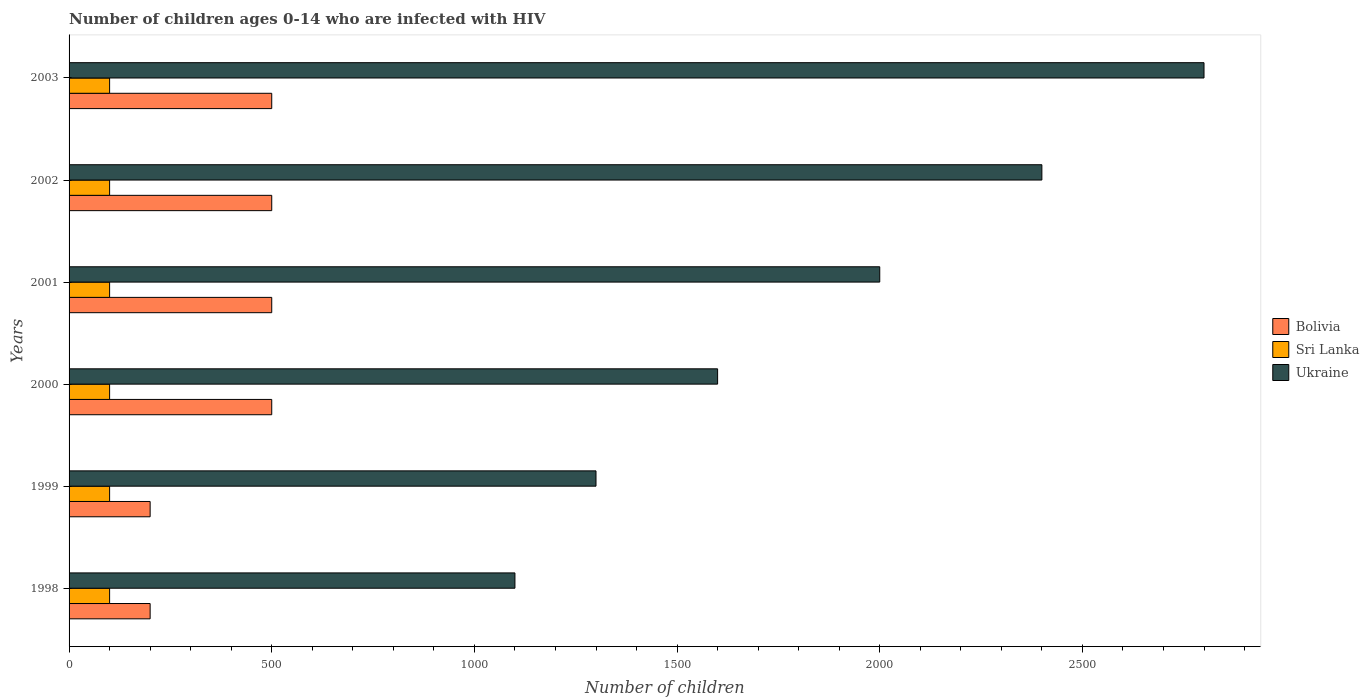How many different coloured bars are there?
Offer a very short reply. 3. Are the number of bars per tick equal to the number of legend labels?
Your response must be concise. Yes. How many bars are there on the 2nd tick from the bottom?
Offer a very short reply. 3. What is the number of HIV infected children in Ukraine in 2001?
Your answer should be compact. 2000. Across all years, what is the maximum number of HIV infected children in Ukraine?
Your answer should be compact. 2800. Across all years, what is the minimum number of HIV infected children in Ukraine?
Keep it short and to the point. 1100. In which year was the number of HIV infected children in Ukraine minimum?
Give a very brief answer. 1998. What is the total number of HIV infected children in Sri Lanka in the graph?
Offer a terse response. 600. What is the difference between the number of HIV infected children in Bolivia in 1999 and that in 2001?
Provide a short and direct response. -300. What is the difference between the number of HIV infected children in Sri Lanka in 1999 and the number of HIV infected children in Bolivia in 2003?
Offer a very short reply. -400. In the year 2001, what is the difference between the number of HIV infected children in Bolivia and number of HIV infected children in Ukraine?
Provide a short and direct response. -1500. Is the number of HIV infected children in Sri Lanka in 2002 less than that in 2003?
Provide a short and direct response. No. Is the difference between the number of HIV infected children in Bolivia in 1999 and 2003 greater than the difference between the number of HIV infected children in Ukraine in 1999 and 2003?
Offer a very short reply. Yes. What is the difference between the highest and the lowest number of HIV infected children in Ukraine?
Keep it short and to the point. 1700. In how many years, is the number of HIV infected children in Sri Lanka greater than the average number of HIV infected children in Sri Lanka taken over all years?
Provide a succinct answer. 0. What does the 3rd bar from the top in 2003 represents?
Give a very brief answer. Bolivia. What does the 2nd bar from the bottom in 2000 represents?
Offer a terse response. Sri Lanka. How many years are there in the graph?
Provide a short and direct response. 6. What is the difference between two consecutive major ticks on the X-axis?
Give a very brief answer. 500. Does the graph contain grids?
Ensure brevity in your answer.  No. Where does the legend appear in the graph?
Your answer should be compact. Center right. How many legend labels are there?
Your answer should be compact. 3. What is the title of the graph?
Provide a short and direct response. Number of children ages 0-14 who are infected with HIV. What is the label or title of the X-axis?
Keep it short and to the point. Number of children. What is the label or title of the Y-axis?
Give a very brief answer. Years. What is the Number of children of Sri Lanka in 1998?
Provide a short and direct response. 100. What is the Number of children of Ukraine in 1998?
Give a very brief answer. 1100. What is the Number of children in Ukraine in 1999?
Your answer should be very brief. 1300. What is the Number of children of Sri Lanka in 2000?
Keep it short and to the point. 100. What is the Number of children of Ukraine in 2000?
Keep it short and to the point. 1600. What is the Number of children of Bolivia in 2001?
Your response must be concise. 500. What is the Number of children in Sri Lanka in 2002?
Provide a short and direct response. 100. What is the Number of children in Ukraine in 2002?
Provide a short and direct response. 2400. What is the Number of children of Sri Lanka in 2003?
Give a very brief answer. 100. What is the Number of children of Ukraine in 2003?
Your response must be concise. 2800. Across all years, what is the maximum Number of children of Bolivia?
Your response must be concise. 500. Across all years, what is the maximum Number of children of Ukraine?
Provide a short and direct response. 2800. Across all years, what is the minimum Number of children of Bolivia?
Offer a very short reply. 200. Across all years, what is the minimum Number of children in Ukraine?
Keep it short and to the point. 1100. What is the total Number of children in Bolivia in the graph?
Keep it short and to the point. 2400. What is the total Number of children in Sri Lanka in the graph?
Provide a succinct answer. 600. What is the total Number of children of Ukraine in the graph?
Your answer should be compact. 1.12e+04. What is the difference between the Number of children in Bolivia in 1998 and that in 1999?
Ensure brevity in your answer.  0. What is the difference between the Number of children of Ukraine in 1998 and that in 1999?
Your response must be concise. -200. What is the difference between the Number of children of Bolivia in 1998 and that in 2000?
Provide a short and direct response. -300. What is the difference between the Number of children of Sri Lanka in 1998 and that in 2000?
Give a very brief answer. 0. What is the difference between the Number of children of Ukraine in 1998 and that in 2000?
Offer a terse response. -500. What is the difference between the Number of children of Bolivia in 1998 and that in 2001?
Offer a very short reply. -300. What is the difference between the Number of children of Ukraine in 1998 and that in 2001?
Your answer should be compact. -900. What is the difference between the Number of children of Bolivia in 1998 and that in 2002?
Keep it short and to the point. -300. What is the difference between the Number of children in Ukraine in 1998 and that in 2002?
Provide a short and direct response. -1300. What is the difference between the Number of children of Bolivia in 1998 and that in 2003?
Provide a succinct answer. -300. What is the difference between the Number of children of Ukraine in 1998 and that in 2003?
Your answer should be compact. -1700. What is the difference between the Number of children of Bolivia in 1999 and that in 2000?
Your answer should be very brief. -300. What is the difference between the Number of children in Sri Lanka in 1999 and that in 2000?
Keep it short and to the point. 0. What is the difference between the Number of children in Ukraine in 1999 and that in 2000?
Offer a terse response. -300. What is the difference between the Number of children of Bolivia in 1999 and that in 2001?
Provide a short and direct response. -300. What is the difference between the Number of children in Ukraine in 1999 and that in 2001?
Offer a terse response. -700. What is the difference between the Number of children of Bolivia in 1999 and that in 2002?
Provide a short and direct response. -300. What is the difference between the Number of children in Ukraine in 1999 and that in 2002?
Provide a short and direct response. -1100. What is the difference between the Number of children in Bolivia in 1999 and that in 2003?
Ensure brevity in your answer.  -300. What is the difference between the Number of children of Sri Lanka in 1999 and that in 2003?
Your answer should be compact. 0. What is the difference between the Number of children in Ukraine in 1999 and that in 2003?
Provide a succinct answer. -1500. What is the difference between the Number of children in Bolivia in 2000 and that in 2001?
Offer a very short reply. 0. What is the difference between the Number of children in Ukraine in 2000 and that in 2001?
Offer a very short reply. -400. What is the difference between the Number of children in Bolivia in 2000 and that in 2002?
Provide a short and direct response. 0. What is the difference between the Number of children in Sri Lanka in 2000 and that in 2002?
Provide a short and direct response. 0. What is the difference between the Number of children of Ukraine in 2000 and that in 2002?
Offer a terse response. -800. What is the difference between the Number of children of Bolivia in 2000 and that in 2003?
Your response must be concise. 0. What is the difference between the Number of children of Sri Lanka in 2000 and that in 2003?
Offer a very short reply. 0. What is the difference between the Number of children of Ukraine in 2000 and that in 2003?
Your answer should be compact. -1200. What is the difference between the Number of children of Ukraine in 2001 and that in 2002?
Keep it short and to the point. -400. What is the difference between the Number of children in Bolivia in 2001 and that in 2003?
Offer a very short reply. 0. What is the difference between the Number of children in Ukraine in 2001 and that in 2003?
Keep it short and to the point. -800. What is the difference between the Number of children in Sri Lanka in 2002 and that in 2003?
Ensure brevity in your answer.  0. What is the difference between the Number of children in Ukraine in 2002 and that in 2003?
Your answer should be compact. -400. What is the difference between the Number of children in Bolivia in 1998 and the Number of children in Ukraine in 1999?
Offer a terse response. -1100. What is the difference between the Number of children of Sri Lanka in 1998 and the Number of children of Ukraine in 1999?
Your answer should be very brief. -1200. What is the difference between the Number of children of Bolivia in 1998 and the Number of children of Sri Lanka in 2000?
Your response must be concise. 100. What is the difference between the Number of children in Bolivia in 1998 and the Number of children in Ukraine in 2000?
Your answer should be very brief. -1400. What is the difference between the Number of children in Sri Lanka in 1998 and the Number of children in Ukraine in 2000?
Offer a very short reply. -1500. What is the difference between the Number of children in Bolivia in 1998 and the Number of children in Ukraine in 2001?
Provide a succinct answer. -1800. What is the difference between the Number of children of Sri Lanka in 1998 and the Number of children of Ukraine in 2001?
Ensure brevity in your answer.  -1900. What is the difference between the Number of children in Bolivia in 1998 and the Number of children in Sri Lanka in 2002?
Your response must be concise. 100. What is the difference between the Number of children of Bolivia in 1998 and the Number of children of Ukraine in 2002?
Your answer should be compact. -2200. What is the difference between the Number of children of Sri Lanka in 1998 and the Number of children of Ukraine in 2002?
Provide a succinct answer. -2300. What is the difference between the Number of children in Bolivia in 1998 and the Number of children in Ukraine in 2003?
Ensure brevity in your answer.  -2600. What is the difference between the Number of children of Sri Lanka in 1998 and the Number of children of Ukraine in 2003?
Ensure brevity in your answer.  -2700. What is the difference between the Number of children of Bolivia in 1999 and the Number of children of Ukraine in 2000?
Your answer should be very brief. -1400. What is the difference between the Number of children of Sri Lanka in 1999 and the Number of children of Ukraine in 2000?
Provide a succinct answer. -1500. What is the difference between the Number of children of Bolivia in 1999 and the Number of children of Ukraine in 2001?
Offer a very short reply. -1800. What is the difference between the Number of children of Sri Lanka in 1999 and the Number of children of Ukraine in 2001?
Provide a succinct answer. -1900. What is the difference between the Number of children of Bolivia in 1999 and the Number of children of Sri Lanka in 2002?
Your answer should be compact. 100. What is the difference between the Number of children in Bolivia in 1999 and the Number of children in Ukraine in 2002?
Offer a very short reply. -2200. What is the difference between the Number of children in Sri Lanka in 1999 and the Number of children in Ukraine in 2002?
Ensure brevity in your answer.  -2300. What is the difference between the Number of children of Bolivia in 1999 and the Number of children of Ukraine in 2003?
Make the answer very short. -2600. What is the difference between the Number of children of Sri Lanka in 1999 and the Number of children of Ukraine in 2003?
Ensure brevity in your answer.  -2700. What is the difference between the Number of children of Bolivia in 2000 and the Number of children of Ukraine in 2001?
Your response must be concise. -1500. What is the difference between the Number of children of Sri Lanka in 2000 and the Number of children of Ukraine in 2001?
Your answer should be very brief. -1900. What is the difference between the Number of children in Bolivia in 2000 and the Number of children in Sri Lanka in 2002?
Offer a very short reply. 400. What is the difference between the Number of children of Bolivia in 2000 and the Number of children of Ukraine in 2002?
Offer a very short reply. -1900. What is the difference between the Number of children in Sri Lanka in 2000 and the Number of children in Ukraine in 2002?
Your answer should be very brief. -2300. What is the difference between the Number of children of Bolivia in 2000 and the Number of children of Sri Lanka in 2003?
Make the answer very short. 400. What is the difference between the Number of children in Bolivia in 2000 and the Number of children in Ukraine in 2003?
Your answer should be very brief. -2300. What is the difference between the Number of children of Sri Lanka in 2000 and the Number of children of Ukraine in 2003?
Provide a short and direct response. -2700. What is the difference between the Number of children in Bolivia in 2001 and the Number of children in Ukraine in 2002?
Give a very brief answer. -1900. What is the difference between the Number of children of Sri Lanka in 2001 and the Number of children of Ukraine in 2002?
Offer a terse response. -2300. What is the difference between the Number of children of Bolivia in 2001 and the Number of children of Ukraine in 2003?
Give a very brief answer. -2300. What is the difference between the Number of children in Sri Lanka in 2001 and the Number of children in Ukraine in 2003?
Your response must be concise. -2700. What is the difference between the Number of children in Bolivia in 2002 and the Number of children in Ukraine in 2003?
Give a very brief answer. -2300. What is the difference between the Number of children of Sri Lanka in 2002 and the Number of children of Ukraine in 2003?
Your response must be concise. -2700. What is the average Number of children of Ukraine per year?
Offer a terse response. 1866.67. In the year 1998, what is the difference between the Number of children in Bolivia and Number of children in Ukraine?
Provide a short and direct response. -900. In the year 1998, what is the difference between the Number of children of Sri Lanka and Number of children of Ukraine?
Give a very brief answer. -1000. In the year 1999, what is the difference between the Number of children in Bolivia and Number of children in Ukraine?
Keep it short and to the point. -1100. In the year 1999, what is the difference between the Number of children of Sri Lanka and Number of children of Ukraine?
Provide a succinct answer. -1200. In the year 2000, what is the difference between the Number of children of Bolivia and Number of children of Sri Lanka?
Your response must be concise. 400. In the year 2000, what is the difference between the Number of children in Bolivia and Number of children in Ukraine?
Give a very brief answer. -1100. In the year 2000, what is the difference between the Number of children in Sri Lanka and Number of children in Ukraine?
Keep it short and to the point. -1500. In the year 2001, what is the difference between the Number of children in Bolivia and Number of children in Ukraine?
Offer a terse response. -1500. In the year 2001, what is the difference between the Number of children of Sri Lanka and Number of children of Ukraine?
Provide a short and direct response. -1900. In the year 2002, what is the difference between the Number of children in Bolivia and Number of children in Ukraine?
Provide a short and direct response. -1900. In the year 2002, what is the difference between the Number of children of Sri Lanka and Number of children of Ukraine?
Provide a short and direct response. -2300. In the year 2003, what is the difference between the Number of children in Bolivia and Number of children in Ukraine?
Provide a short and direct response. -2300. In the year 2003, what is the difference between the Number of children in Sri Lanka and Number of children in Ukraine?
Offer a very short reply. -2700. What is the ratio of the Number of children of Ukraine in 1998 to that in 1999?
Make the answer very short. 0.85. What is the ratio of the Number of children of Ukraine in 1998 to that in 2000?
Offer a very short reply. 0.69. What is the ratio of the Number of children in Sri Lanka in 1998 to that in 2001?
Your answer should be very brief. 1. What is the ratio of the Number of children of Ukraine in 1998 to that in 2001?
Give a very brief answer. 0.55. What is the ratio of the Number of children of Bolivia in 1998 to that in 2002?
Your answer should be compact. 0.4. What is the ratio of the Number of children in Ukraine in 1998 to that in 2002?
Your answer should be very brief. 0.46. What is the ratio of the Number of children of Sri Lanka in 1998 to that in 2003?
Offer a terse response. 1. What is the ratio of the Number of children in Ukraine in 1998 to that in 2003?
Your answer should be compact. 0.39. What is the ratio of the Number of children in Bolivia in 1999 to that in 2000?
Ensure brevity in your answer.  0.4. What is the ratio of the Number of children of Sri Lanka in 1999 to that in 2000?
Ensure brevity in your answer.  1. What is the ratio of the Number of children in Ukraine in 1999 to that in 2000?
Your answer should be compact. 0.81. What is the ratio of the Number of children in Sri Lanka in 1999 to that in 2001?
Ensure brevity in your answer.  1. What is the ratio of the Number of children of Ukraine in 1999 to that in 2001?
Keep it short and to the point. 0.65. What is the ratio of the Number of children of Sri Lanka in 1999 to that in 2002?
Offer a very short reply. 1. What is the ratio of the Number of children in Ukraine in 1999 to that in 2002?
Ensure brevity in your answer.  0.54. What is the ratio of the Number of children in Ukraine in 1999 to that in 2003?
Offer a terse response. 0.46. What is the ratio of the Number of children of Sri Lanka in 2000 to that in 2001?
Your response must be concise. 1. What is the ratio of the Number of children of Ukraine in 2000 to that in 2001?
Keep it short and to the point. 0.8. What is the ratio of the Number of children in Sri Lanka in 2000 to that in 2002?
Your answer should be very brief. 1. What is the ratio of the Number of children in Sri Lanka in 2000 to that in 2003?
Offer a terse response. 1. What is the ratio of the Number of children of Sri Lanka in 2001 to that in 2002?
Offer a terse response. 1. What is the ratio of the Number of children of Ukraine in 2001 to that in 2002?
Offer a terse response. 0.83. What is the ratio of the Number of children of Sri Lanka in 2001 to that in 2003?
Offer a terse response. 1. What is the ratio of the Number of children of Ukraine in 2001 to that in 2003?
Ensure brevity in your answer.  0.71. What is the ratio of the Number of children in Bolivia in 2002 to that in 2003?
Offer a very short reply. 1. What is the ratio of the Number of children in Sri Lanka in 2002 to that in 2003?
Offer a terse response. 1. What is the ratio of the Number of children of Ukraine in 2002 to that in 2003?
Provide a succinct answer. 0.86. What is the difference between the highest and the second highest Number of children of Sri Lanka?
Your answer should be very brief. 0. What is the difference between the highest and the second highest Number of children of Ukraine?
Your answer should be compact. 400. What is the difference between the highest and the lowest Number of children in Bolivia?
Give a very brief answer. 300. What is the difference between the highest and the lowest Number of children in Sri Lanka?
Your answer should be very brief. 0. What is the difference between the highest and the lowest Number of children of Ukraine?
Your response must be concise. 1700. 